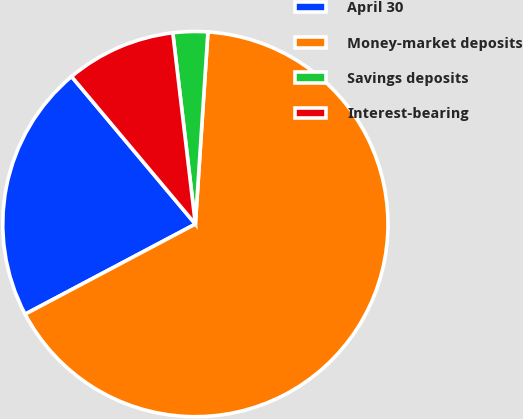<chart> <loc_0><loc_0><loc_500><loc_500><pie_chart><fcel>April 30<fcel>Money-market deposits<fcel>Savings deposits<fcel>Interest-bearing<nl><fcel>21.64%<fcel>66.22%<fcel>2.91%<fcel>9.24%<nl></chart> 